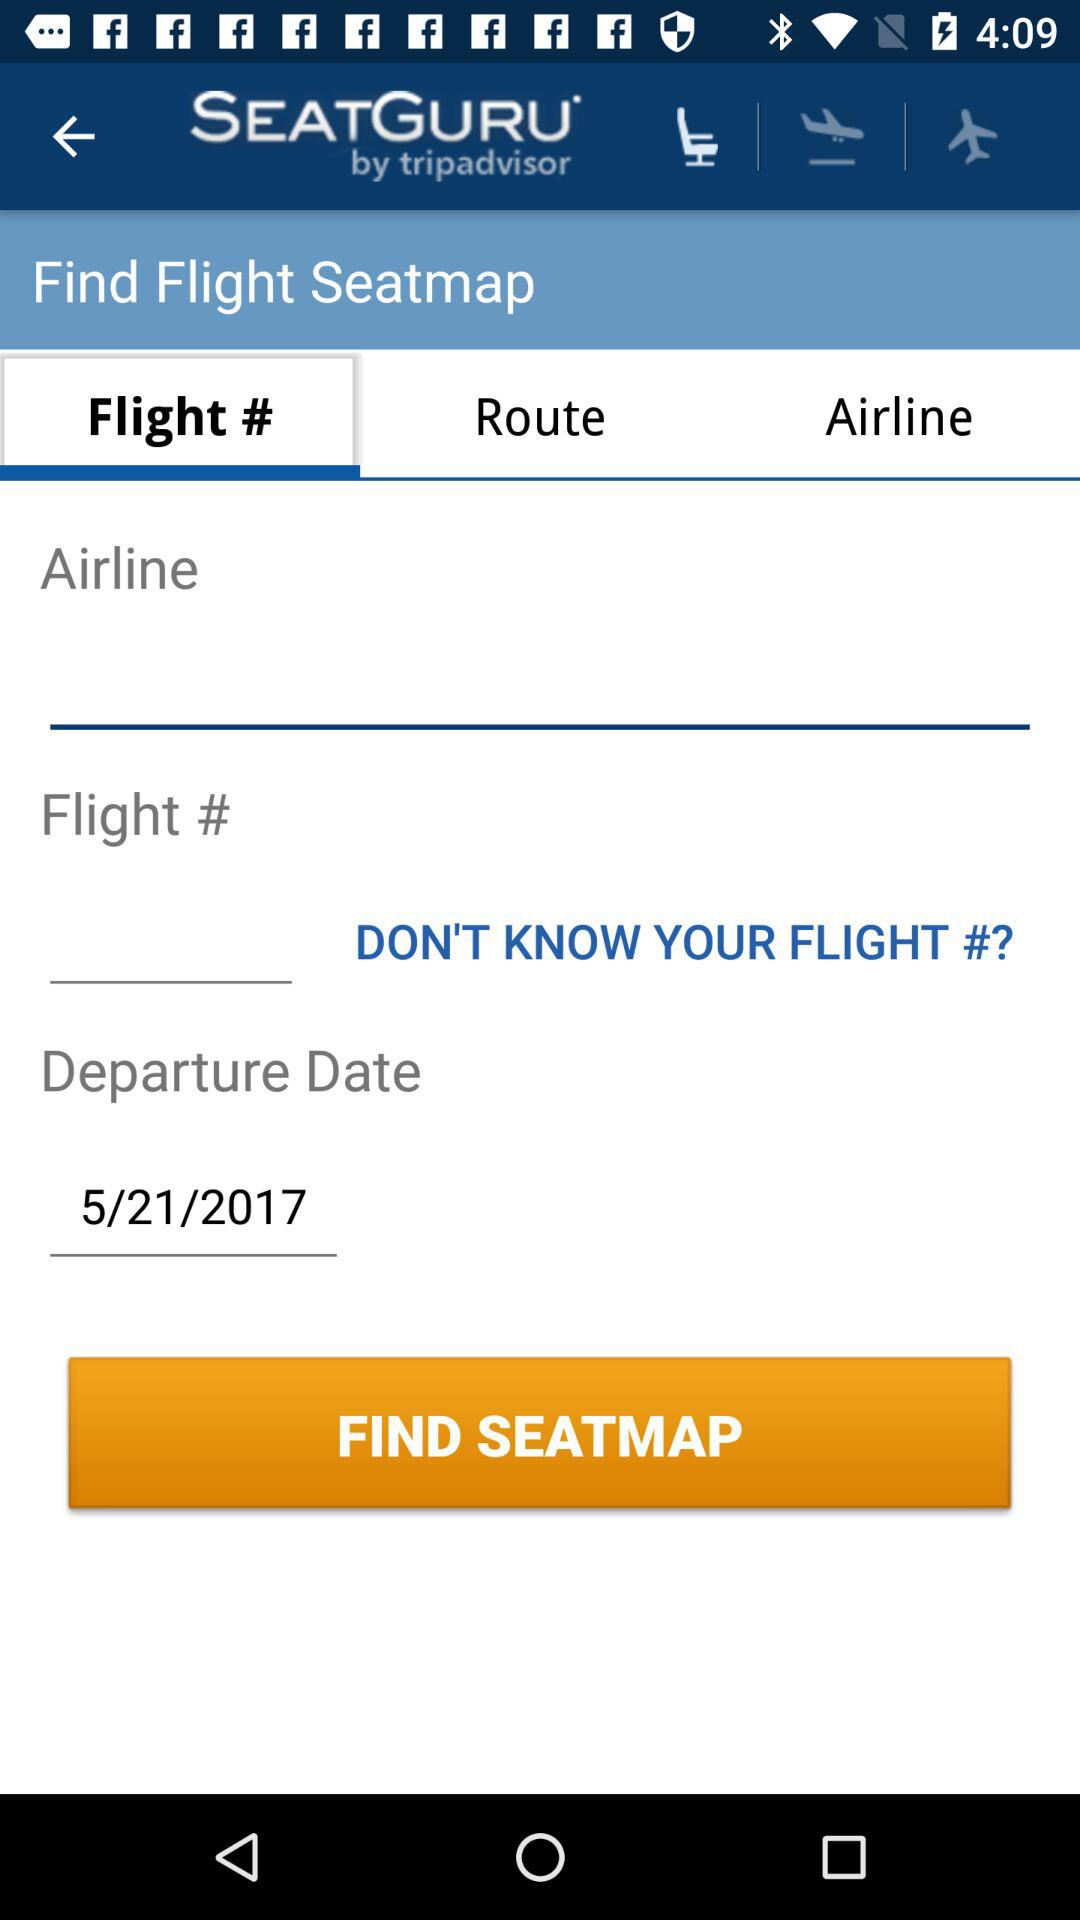What is the departure date? The departure date is May 21, 2017. 